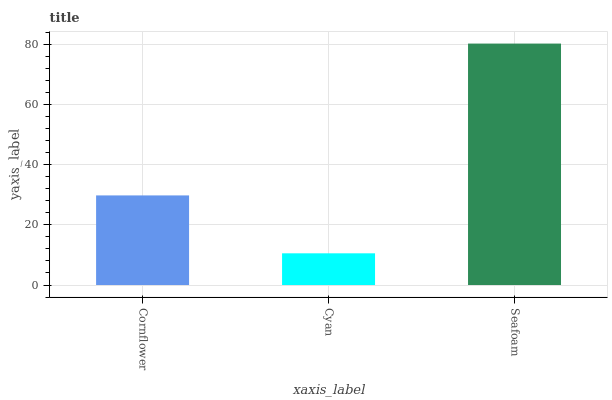Is Seafoam the minimum?
Answer yes or no. No. Is Cyan the maximum?
Answer yes or no. No. Is Seafoam greater than Cyan?
Answer yes or no. Yes. Is Cyan less than Seafoam?
Answer yes or no. Yes. Is Cyan greater than Seafoam?
Answer yes or no. No. Is Seafoam less than Cyan?
Answer yes or no. No. Is Cornflower the high median?
Answer yes or no. Yes. Is Cornflower the low median?
Answer yes or no. Yes. Is Seafoam the high median?
Answer yes or no. No. Is Seafoam the low median?
Answer yes or no. No. 